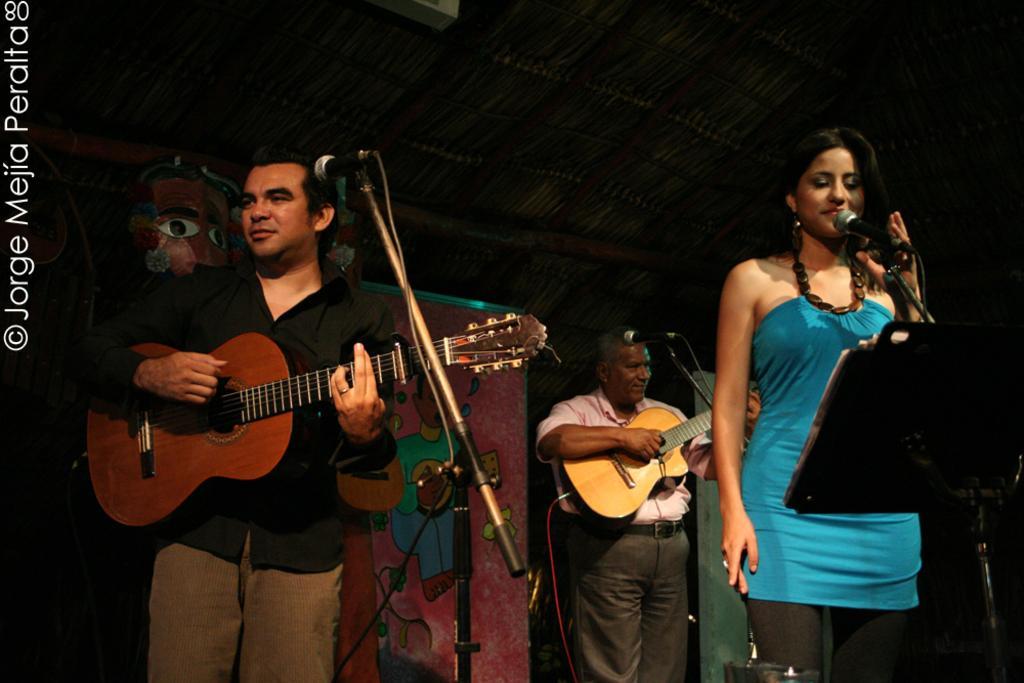How would you summarize this image in a sentence or two? On the background we can see a poster. Here we can see one woman standing in front of a mic and singing. We can see two men standing in front of a mic and playing guitars. 